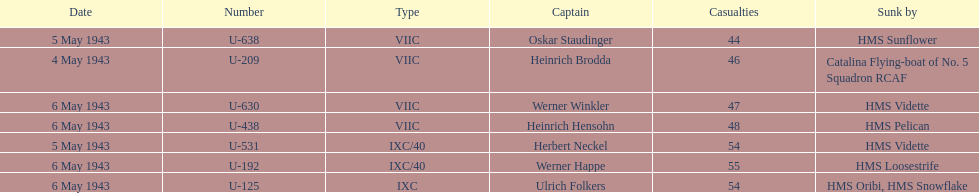Which u-boat was the pioneer in sinking? U-209. Would you be able to parse every entry in this table? {'header': ['Date', 'Number', 'Type', 'Captain', 'Casualties', 'Sunk by'], 'rows': [['5 May 1943', 'U-638', 'VIIC', 'Oskar Staudinger', '44', 'HMS Sunflower'], ['4 May 1943', 'U-209', 'VIIC', 'Heinrich Brodda', '46', 'Catalina Flying-boat of No. 5 Squadron RCAF'], ['6 May 1943', 'U-630', 'VIIC', 'Werner Winkler', '47', 'HMS Vidette'], ['6 May 1943', 'U-438', 'VIIC', 'Heinrich Hensohn', '48', 'HMS Pelican'], ['5 May 1943', 'U-531', 'IXC/40', 'Herbert Neckel', '54', 'HMS Vidette'], ['6 May 1943', 'U-192', 'IXC/40', 'Werner Happe', '55', 'HMS Loosestrife'], ['6 May 1943', 'U-125', 'IXC', 'Ulrich Folkers', '54', 'HMS Oribi, HMS Snowflake']]} 